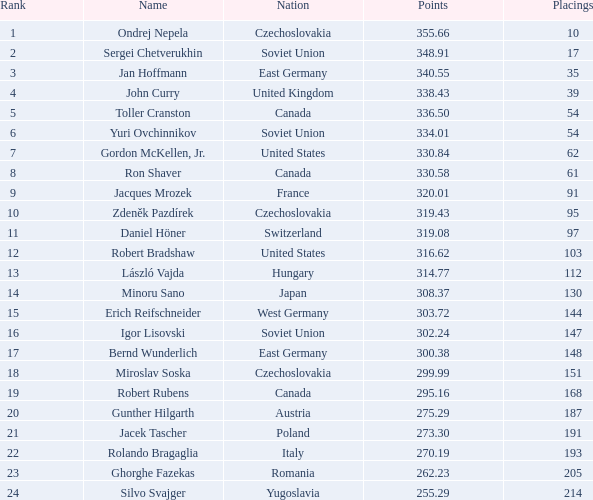How many Placings have Points smaller than 330.84, and a Name of silvo svajger? 1.0. 